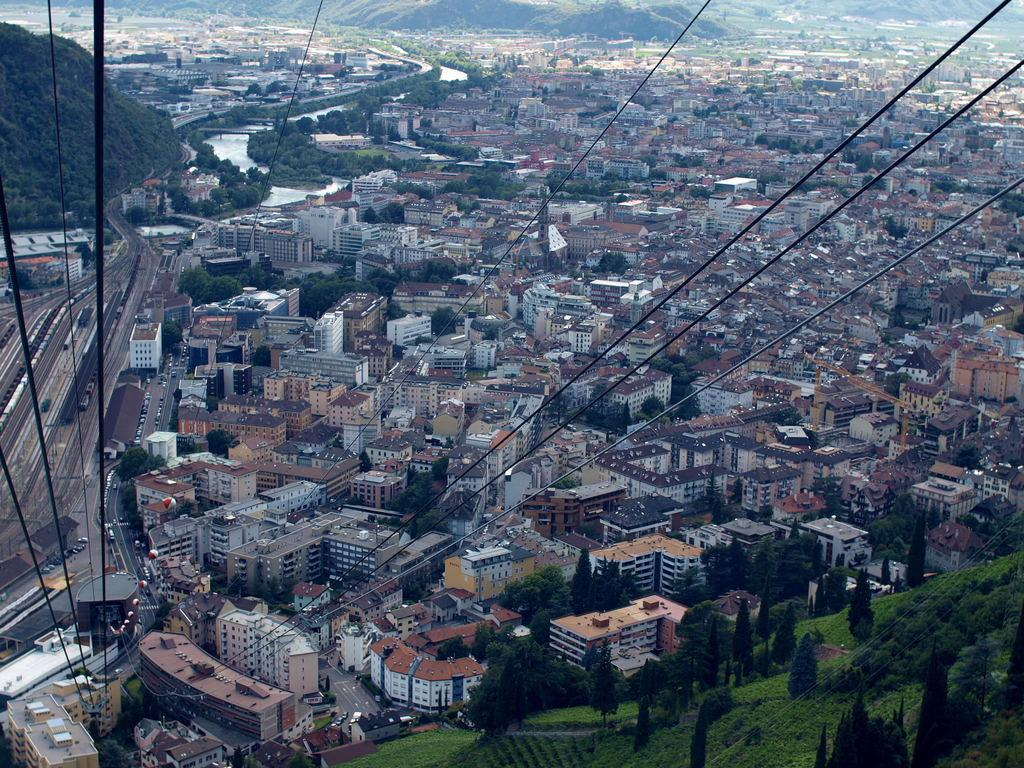What is the main focus of the image? The main focus of the image is the many buildings in the center. What type of natural elements can be seen in the image? There are trees and a mountain visible in the image. Are there any objects that suggest an activity or purpose in the image? Yes, there are ropes in the image, which might indicate climbing or other outdoor activities. What type of board can be seen being rubbed by a pet in the image? There is no board or pet present in the image. How does the mountain rub against the trees in the image? The mountain does not rub against the trees in the image; it is a stationary geological feature. 